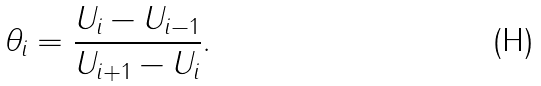<formula> <loc_0><loc_0><loc_500><loc_500>\theta _ { i } = \frac { U _ { i } - U _ { i - 1 } } { U _ { i + 1 } - U _ { i } } .</formula> 